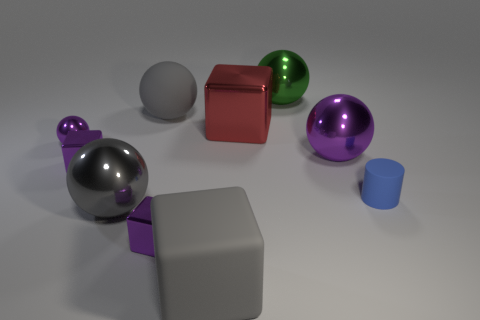Is there any other thing that has the same color as the rubber cube?
Make the answer very short. Yes. What is the color of the metallic thing that is both right of the gray rubber ball and in front of the blue matte cylinder?
Give a very brief answer. Purple. There is a purple block in front of the cylinder; is it the same size as the tiny blue thing?
Provide a short and direct response. Yes. Are there more large balls that are to the right of the green metal ball than big yellow cylinders?
Make the answer very short. Yes. Is the shape of the green metallic thing the same as the big purple thing?
Keep it short and to the point. Yes. What size is the blue cylinder?
Your answer should be compact. Small. Is the number of large shiny balls that are behind the blue thing greater than the number of shiny spheres that are to the right of the large gray rubber cube?
Keep it short and to the point. No. There is a tiny metallic ball; are there any gray metallic objects to the right of it?
Give a very brief answer. Yes. Is there a gray matte object of the same size as the green shiny thing?
Your response must be concise. Yes. There is a large block that is the same material as the large purple thing; what color is it?
Your response must be concise. Red. 